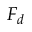<formula> <loc_0><loc_0><loc_500><loc_500>F _ { d }</formula> 